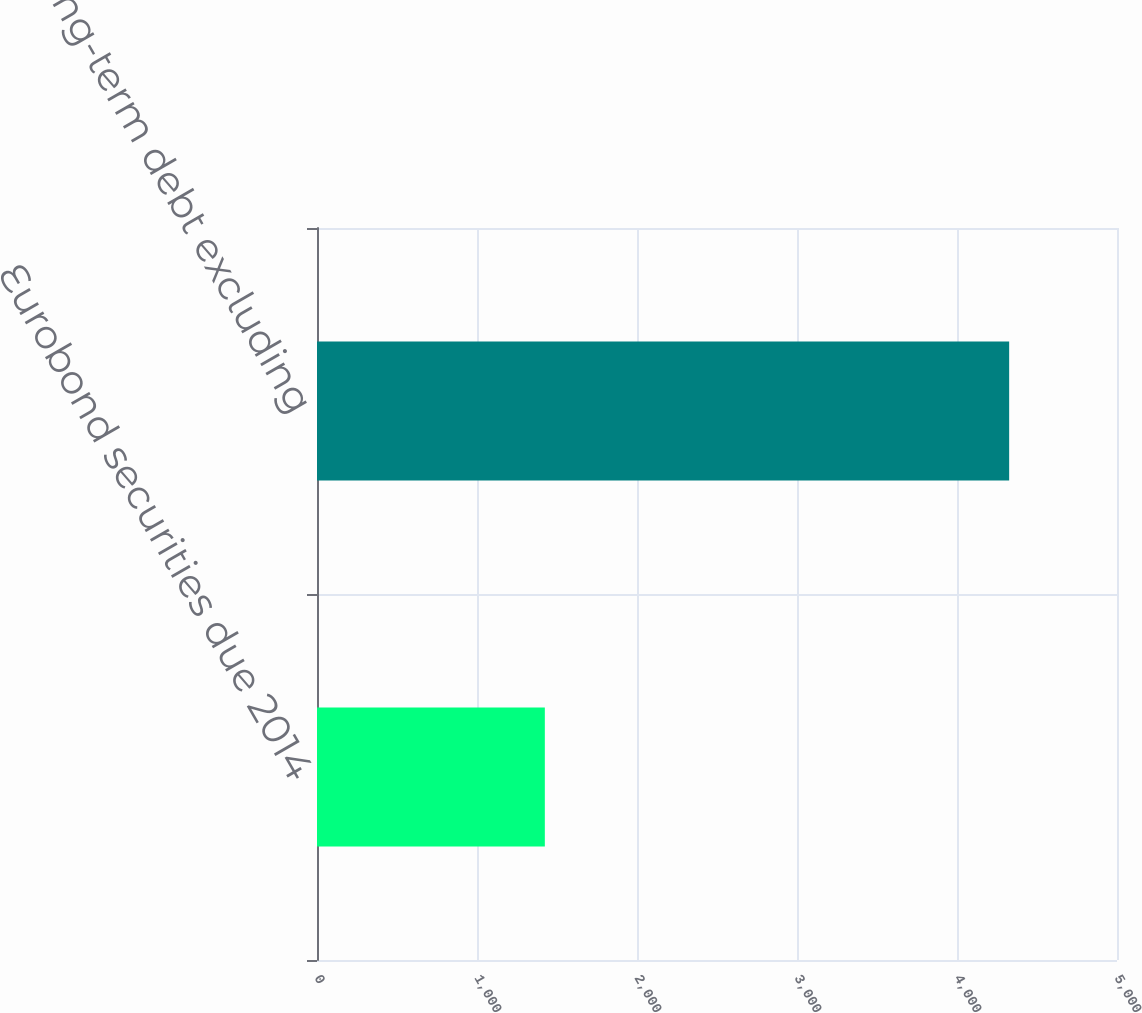Convert chart. <chart><loc_0><loc_0><loc_500><loc_500><bar_chart><fcel>Eurobond securities due 2014<fcel>Long-term debt excluding<nl><fcel>1424<fcel>4326<nl></chart> 